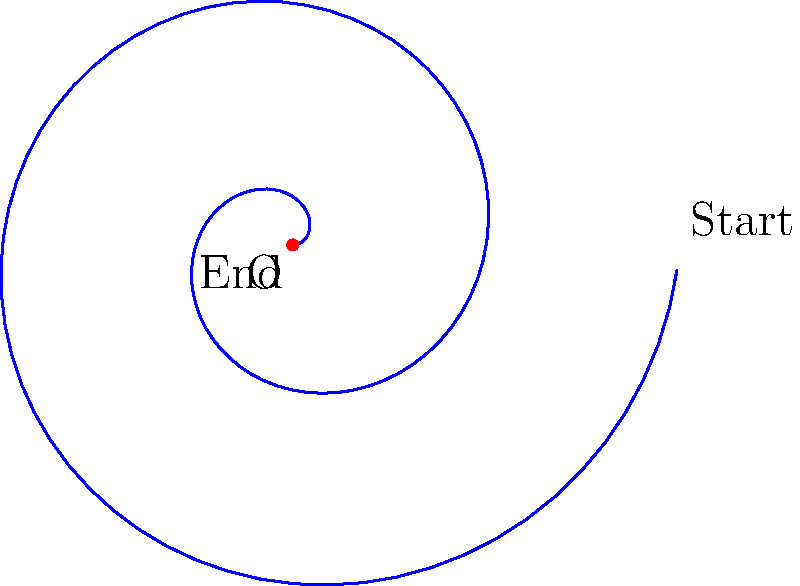In somatic therapy, we often use visual metaphors to represent the release of tension in muscles. Consider the spiral shown above as a representation of muscle tension unwinding. If the spiral starts at the outermost point and winds inward towards point O, and the length of the spiral represents the time taken for the muscle to relax, calculate the total angular displacement (in radians) from start to finish. Assume the spiral follows the equation $r = a\theta$, where $a = 0.1$ and the spiral makes exactly two complete revolutions. To solve this problem, we need to follow these steps:

1) First, recall that for a spiral defined by $r = a\theta$, $\theta$ represents the angular displacement in radians.

2) We're told that the spiral makes exactly two complete revolutions. One complete revolution is $2\pi$ radians.

3) Therefore, for two complete revolutions, we need to calculate:

   $$\theta_{total} = 2 \times 2\pi = 4\pi \text{ radians}$$

4) We can verify this using the given information:
   - The spiral starts at the outermost point
   - It winds inward towards point O
   - It makes exactly two complete revolutions

5) This $4\pi$ radians represents the total angular displacement from the start of the unwinding (outermost point) to the end (point O).

6) In the context of somatic therapy, this could be interpreted as the complete process of tension release, from the most tense state (outermost point) to the fully relaxed state (center point O).
Answer: $4\pi$ radians 